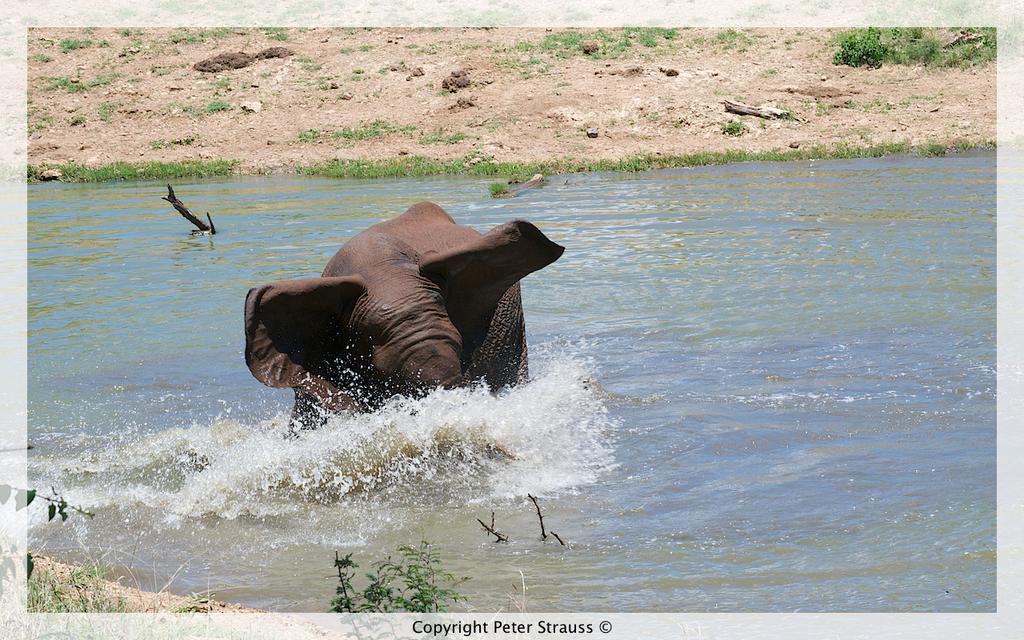What animal is present in the image? There is an elephant in the image. Where is the elephant located in the image? The elephant is standing in the water. What type of vegetation can be seen in the image? There are plants and grass in the image. What part of the natural environment is visible in the image? The ground is visible in the image. What type of apparatus is being used by the elephant in the image? There is no apparatus present in the image; the elephant is simply standing in the water. Can you tell me what color the toothbrush is in the image? There is no toothbrush present in the image. 